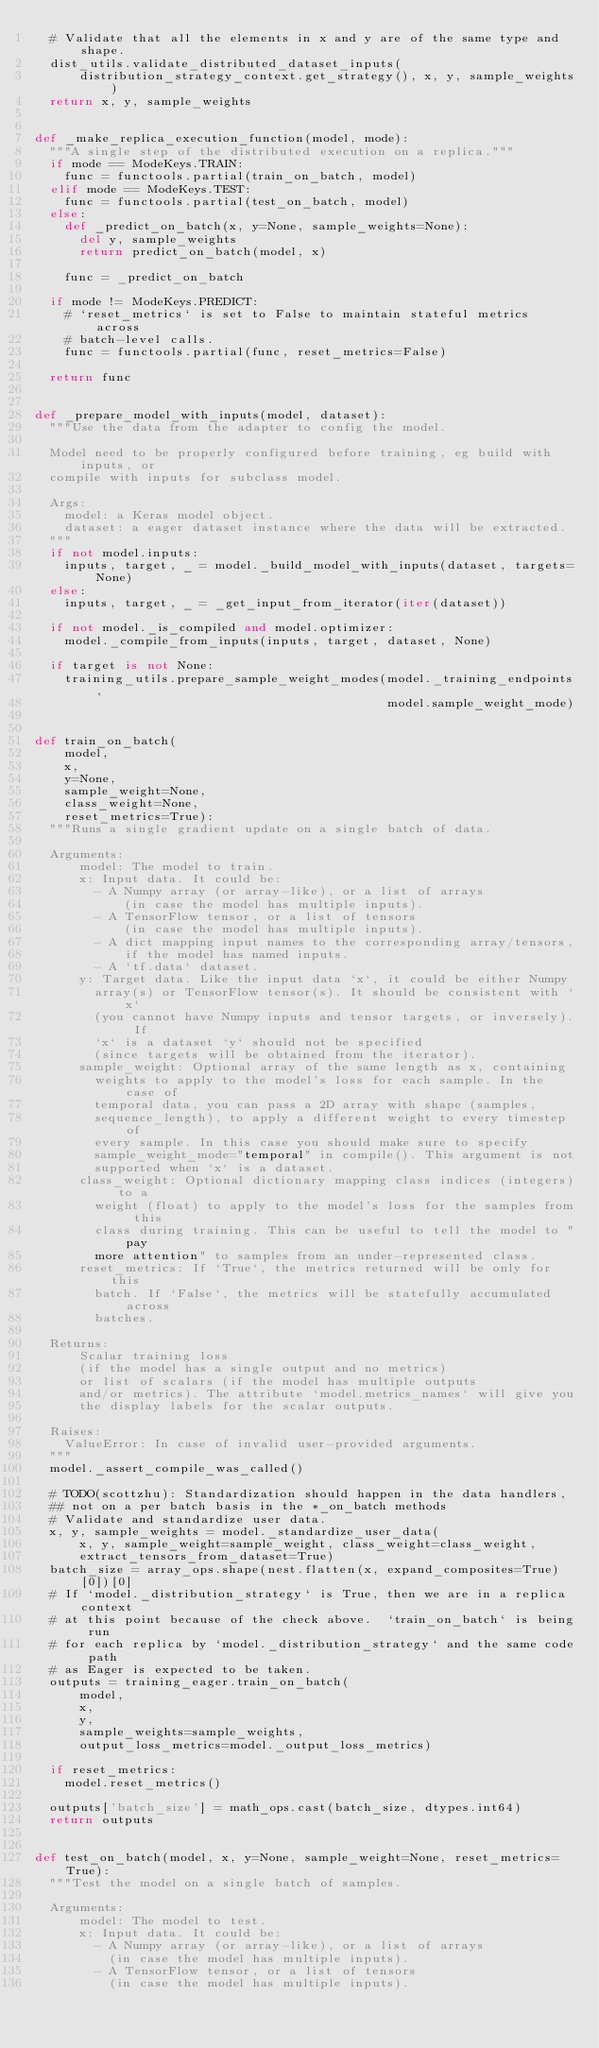<code> <loc_0><loc_0><loc_500><loc_500><_Python_>  # Validate that all the elements in x and y are of the same type and shape.
  dist_utils.validate_distributed_dataset_inputs(
      distribution_strategy_context.get_strategy(), x, y, sample_weights)
  return x, y, sample_weights


def _make_replica_execution_function(model, mode):
  """A single step of the distributed execution on a replica."""
  if mode == ModeKeys.TRAIN:
    func = functools.partial(train_on_batch, model)
  elif mode == ModeKeys.TEST:
    func = functools.partial(test_on_batch, model)
  else:
    def _predict_on_batch(x, y=None, sample_weights=None):
      del y, sample_weights
      return predict_on_batch(model, x)

    func = _predict_on_batch

  if mode != ModeKeys.PREDICT:
    # `reset_metrics` is set to False to maintain stateful metrics across
    # batch-level calls.
    func = functools.partial(func, reset_metrics=False)

  return func


def _prepare_model_with_inputs(model, dataset):
  """Use the data from the adapter to config the model.

  Model need to be properly configured before training, eg build with inputs, or
  compile with inputs for subclass model.

  Args:
    model: a Keras model object.
    dataset: a eager dataset instance where the data will be extracted.
  """
  if not model.inputs:
    inputs, target, _ = model._build_model_with_inputs(dataset, targets=None)
  else:
    inputs, target, _ = _get_input_from_iterator(iter(dataset))

  if not model._is_compiled and model.optimizer:
    model._compile_from_inputs(inputs, target, dataset, None)

  if target is not None:
    training_utils.prepare_sample_weight_modes(model._training_endpoints,
                                               model.sample_weight_mode)


def train_on_batch(
    model,
    x,
    y=None,
    sample_weight=None,
    class_weight=None,
    reset_metrics=True):
  """Runs a single gradient update on a single batch of data.

  Arguments:
      model: The model to train.
      x: Input data. It could be:
        - A Numpy array (or array-like), or a list of arrays
            (in case the model has multiple inputs).
        - A TensorFlow tensor, or a list of tensors
            (in case the model has multiple inputs).
        - A dict mapping input names to the corresponding array/tensors,
            if the model has named inputs.
        - A `tf.data` dataset.
      y: Target data. Like the input data `x`, it could be either Numpy
        array(s) or TensorFlow tensor(s). It should be consistent with `x`
        (you cannot have Numpy inputs and tensor targets, or inversely). If
        `x` is a dataset `y` should not be specified
        (since targets will be obtained from the iterator).
      sample_weight: Optional array of the same length as x, containing
        weights to apply to the model's loss for each sample. In the case of
        temporal data, you can pass a 2D array with shape (samples,
        sequence_length), to apply a different weight to every timestep of
        every sample. In this case you should make sure to specify
        sample_weight_mode="temporal" in compile(). This argument is not
        supported when `x` is a dataset.
      class_weight: Optional dictionary mapping class indices (integers) to a
        weight (float) to apply to the model's loss for the samples from this
        class during training. This can be useful to tell the model to "pay
        more attention" to samples from an under-represented class.
      reset_metrics: If `True`, the metrics returned will be only for this
        batch. If `False`, the metrics will be statefully accumulated across
        batches.

  Returns:
      Scalar training loss
      (if the model has a single output and no metrics)
      or list of scalars (if the model has multiple outputs
      and/or metrics). The attribute `model.metrics_names` will give you
      the display labels for the scalar outputs.

  Raises:
    ValueError: In case of invalid user-provided arguments.
  """
  model._assert_compile_was_called()

  # TODO(scottzhu): Standardization should happen in the data handlers,
  ## not on a per batch basis in the *_on_batch methods
  # Validate and standardize user data.
  x, y, sample_weights = model._standardize_user_data(
      x, y, sample_weight=sample_weight, class_weight=class_weight,
      extract_tensors_from_dataset=True)
  batch_size = array_ops.shape(nest.flatten(x, expand_composites=True)[0])[0]
  # If `model._distribution_strategy` is True, then we are in a replica context
  # at this point because of the check above.  `train_on_batch` is being run
  # for each replica by `model._distribution_strategy` and the same code path
  # as Eager is expected to be taken.
  outputs = training_eager.train_on_batch(
      model,
      x,
      y,
      sample_weights=sample_weights,
      output_loss_metrics=model._output_loss_metrics)

  if reset_metrics:
    model.reset_metrics()

  outputs['batch_size'] = math_ops.cast(batch_size, dtypes.int64)
  return outputs


def test_on_batch(model, x, y=None, sample_weight=None, reset_metrics=True):
  """Test the model on a single batch of samples.

  Arguments:
      model: The model to test.
      x: Input data. It could be:
        - A Numpy array (or array-like), or a list of arrays
          (in case the model has multiple inputs).
        - A TensorFlow tensor, or a list of tensors
          (in case the model has multiple inputs).</code> 